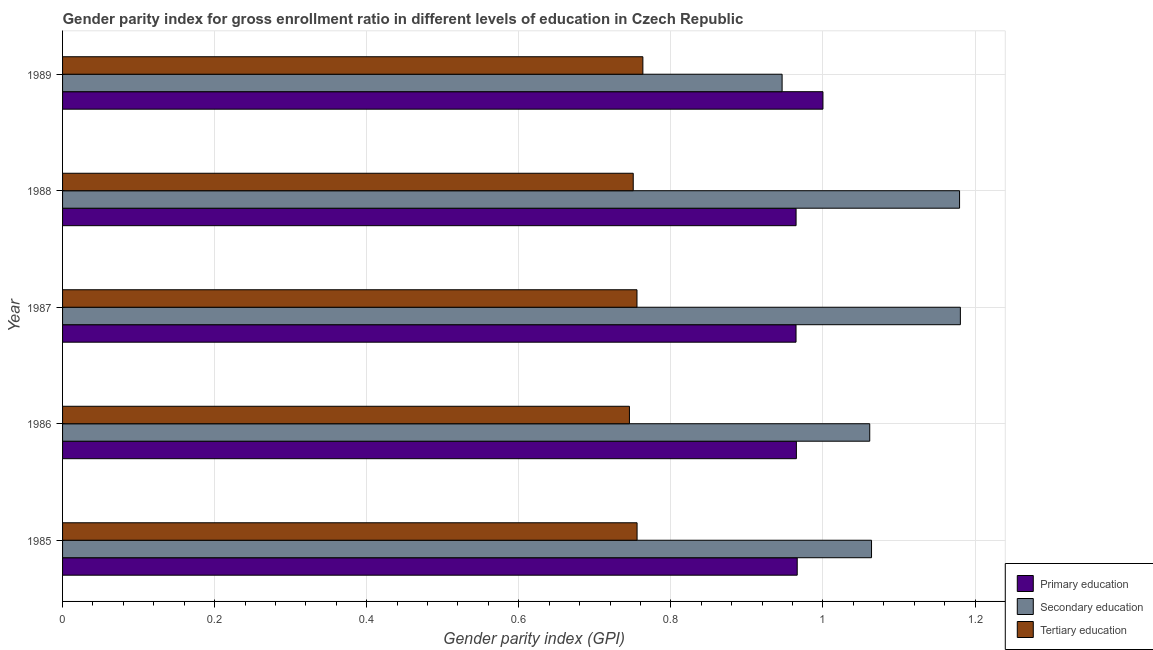How many different coloured bars are there?
Offer a terse response. 3. Are the number of bars per tick equal to the number of legend labels?
Offer a terse response. Yes. Are the number of bars on each tick of the Y-axis equal?
Offer a terse response. Yes. What is the label of the 1st group of bars from the top?
Your answer should be very brief. 1989. In how many cases, is the number of bars for a given year not equal to the number of legend labels?
Provide a short and direct response. 0. What is the gender parity index in secondary education in 1986?
Your response must be concise. 1.06. Across all years, what is the maximum gender parity index in primary education?
Provide a succinct answer. 1. Across all years, what is the minimum gender parity index in primary education?
Offer a very short reply. 0.96. In which year was the gender parity index in tertiary education maximum?
Offer a very short reply. 1989. In which year was the gender parity index in secondary education minimum?
Offer a terse response. 1989. What is the total gender parity index in secondary education in the graph?
Your response must be concise. 5.43. What is the difference between the gender parity index in secondary education in 1987 and that in 1988?
Your answer should be very brief. 0. What is the difference between the gender parity index in tertiary education in 1987 and the gender parity index in primary education in 1986?
Provide a short and direct response. -0.21. What is the average gender parity index in primary education per year?
Give a very brief answer. 0.97. In the year 1985, what is the difference between the gender parity index in secondary education and gender parity index in primary education?
Provide a succinct answer. 0.1. In how many years, is the gender parity index in primary education greater than 0.04 ?
Offer a very short reply. 5. What is the ratio of the gender parity index in primary education in 1985 to that in 1986?
Your response must be concise. 1. Is the gender parity index in primary education in 1985 less than that in 1989?
Offer a terse response. Yes. Is the difference between the gender parity index in secondary education in 1985 and 1986 greater than the difference between the gender parity index in primary education in 1985 and 1986?
Offer a terse response. Yes. What is the difference between the highest and the second highest gender parity index in secondary education?
Offer a terse response. 0. What is the difference between the highest and the lowest gender parity index in tertiary education?
Your answer should be very brief. 0.02. What does the 1st bar from the top in 1985 represents?
Keep it short and to the point. Tertiary education. What does the 1st bar from the bottom in 1985 represents?
Your answer should be very brief. Primary education. Is it the case that in every year, the sum of the gender parity index in primary education and gender parity index in secondary education is greater than the gender parity index in tertiary education?
Provide a succinct answer. Yes. Are all the bars in the graph horizontal?
Keep it short and to the point. Yes. How many years are there in the graph?
Provide a short and direct response. 5. Does the graph contain any zero values?
Make the answer very short. No. Where does the legend appear in the graph?
Make the answer very short. Bottom right. How are the legend labels stacked?
Make the answer very short. Vertical. What is the title of the graph?
Offer a terse response. Gender parity index for gross enrollment ratio in different levels of education in Czech Republic. What is the label or title of the X-axis?
Make the answer very short. Gender parity index (GPI). What is the Gender parity index (GPI) of Primary education in 1985?
Make the answer very short. 0.97. What is the Gender parity index (GPI) in Secondary education in 1985?
Make the answer very short. 1.06. What is the Gender parity index (GPI) in Tertiary education in 1985?
Your response must be concise. 0.76. What is the Gender parity index (GPI) in Primary education in 1986?
Provide a succinct answer. 0.97. What is the Gender parity index (GPI) in Secondary education in 1986?
Give a very brief answer. 1.06. What is the Gender parity index (GPI) in Tertiary education in 1986?
Offer a very short reply. 0.75. What is the Gender parity index (GPI) of Primary education in 1987?
Your answer should be very brief. 0.96. What is the Gender parity index (GPI) of Secondary education in 1987?
Offer a very short reply. 1.18. What is the Gender parity index (GPI) of Tertiary education in 1987?
Ensure brevity in your answer.  0.76. What is the Gender parity index (GPI) in Primary education in 1988?
Provide a succinct answer. 0.96. What is the Gender parity index (GPI) in Secondary education in 1988?
Provide a short and direct response. 1.18. What is the Gender parity index (GPI) of Tertiary education in 1988?
Your response must be concise. 0.75. What is the Gender parity index (GPI) of Primary education in 1989?
Your answer should be compact. 1. What is the Gender parity index (GPI) of Secondary education in 1989?
Provide a short and direct response. 0.95. What is the Gender parity index (GPI) in Tertiary education in 1989?
Offer a terse response. 0.76. Across all years, what is the maximum Gender parity index (GPI) in Primary education?
Give a very brief answer. 1. Across all years, what is the maximum Gender parity index (GPI) in Secondary education?
Provide a succinct answer. 1.18. Across all years, what is the maximum Gender parity index (GPI) in Tertiary education?
Offer a terse response. 0.76. Across all years, what is the minimum Gender parity index (GPI) in Primary education?
Offer a terse response. 0.96. Across all years, what is the minimum Gender parity index (GPI) of Secondary education?
Provide a short and direct response. 0.95. Across all years, what is the minimum Gender parity index (GPI) in Tertiary education?
Make the answer very short. 0.75. What is the total Gender parity index (GPI) in Primary education in the graph?
Offer a very short reply. 4.86. What is the total Gender parity index (GPI) in Secondary education in the graph?
Provide a succinct answer. 5.43. What is the total Gender parity index (GPI) in Tertiary education in the graph?
Give a very brief answer. 3.77. What is the difference between the Gender parity index (GPI) in Primary education in 1985 and that in 1986?
Provide a succinct answer. 0. What is the difference between the Gender parity index (GPI) in Secondary education in 1985 and that in 1986?
Keep it short and to the point. 0. What is the difference between the Gender parity index (GPI) in Tertiary education in 1985 and that in 1986?
Make the answer very short. 0.01. What is the difference between the Gender parity index (GPI) of Primary education in 1985 and that in 1987?
Offer a terse response. 0. What is the difference between the Gender parity index (GPI) of Secondary education in 1985 and that in 1987?
Provide a succinct answer. -0.12. What is the difference between the Gender parity index (GPI) of Primary education in 1985 and that in 1988?
Offer a very short reply. 0. What is the difference between the Gender parity index (GPI) in Secondary education in 1985 and that in 1988?
Make the answer very short. -0.12. What is the difference between the Gender parity index (GPI) in Tertiary education in 1985 and that in 1988?
Your answer should be very brief. 0.01. What is the difference between the Gender parity index (GPI) in Primary education in 1985 and that in 1989?
Offer a very short reply. -0.03. What is the difference between the Gender parity index (GPI) of Secondary education in 1985 and that in 1989?
Ensure brevity in your answer.  0.12. What is the difference between the Gender parity index (GPI) of Tertiary education in 1985 and that in 1989?
Offer a very short reply. -0.01. What is the difference between the Gender parity index (GPI) of Primary education in 1986 and that in 1987?
Offer a very short reply. 0. What is the difference between the Gender parity index (GPI) in Secondary education in 1986 and that in 1987?
Make the answer very short. -0.12. What is the difference between the Gender parity index (GPI) of Tertiary education in 1986 and that in 1987?
Keep it short and to the point. -0.01. What is the difference between the Gender parity index (GPI) in Secondary education in 1986 and that in 1988?
Provide a short and direct response. -0.12. What is the difference between the Gender parity index (GPI) in Tertiary education in 1986 and that in 1988?
Keep it short and to the point. -0.01. What is the difference between the Gender parity index (GPI) in Primary education in 1986 and that in 1989?
Your response must be concise. -0.03. What is the difference between the Gender parity index (GPI) in Secondary education in 1986 and that in 1989?
Ensure brevity in your answer.  0.12. What is the difference between the Gender parity index (GPI) of Tertiary education in 1986 and that in 1989?
Offer a terse response. -0.02. What is the difference between the Gender parity index (GPI) of Primary education in 1987 and that in 1988?
Your answer should be compact. -0. What is the difference between the Gender parity index (GPI) of Secondary education in 1987 and that in 1988?
Your answer should be very brief. 0. What is the difference between the Gender parity index (GPI) of Tertiary education in 1987 and that in 1988?
Make the answer very short. 0. What is the difference between the Gender parity index (GPI) in Primary education in 1987 and that in 1989?
Offer a very short reply. -0.04. What is the difference between the Gender parity index (GPI) in Secondary education in 1987 and that in 1989?
Keep it short and to the point. 0.23. What is the difference between the Gender parity index (GPI) of Tertiary education in 1987 and that in 1989?
Ensure brevity in your answer.  -0.01. What is the difference between the Gender parity index (GPI) in Primary education in 1988 and that in 1989?
Ensure brevity in your answer.  -0.04. What is the difference between the Gender parity index (GPI) of Secondary education in 1988 and that in 1989?
Offer a terse response. 0.23. What is the difference between the Gender parity index (GPI) in Tertiary education in 1988 and that in 1989?
Provide a succinct answer. -0.01. What is the difference between the Gender parity index (GPI) in Primary education in 1985 and the Gender parity index (GPI) in Secondary education in 1986?
Your answer should be very brief. -0.1. What is the difference between the Gender parity index (GPI) in Primary education in 1985 and the Gender parity index (GPI) in Tertiary education in 1986?
Make the answer very short. 0.22. What is the difference between the Gender parity index (GPI) of Secondary education in 1985 and the Gender parity index (GPI) of Tertiary education in 1986?
Give a very brief answer. 0.32. What is the difference between the Gender parity index (GPI) in Primary education in 1985 and the Gender parity index (GPI) in Secondary education in 1987?
Your response must be concise. -0.21. What is the difference between the Gender parity index (GPI) of Primary education in 1985 and the Gender parity index (GPI) of Tertiary education in 1987?
Offer a very short reply. 0.21. What is the difference between the Gender parity index (GPI) in Secondary education in 1985 and the Gender parity index (GPI) in Tertiary education in 1987?
Keep it short and to the point. 0.31. What is the difference between the Gender parity index (GPI) in Primary education in 1985 and the Gender parity index (GPI) in Secondary education in 1988?
Offer a terse response. -0.21. What is the difference between the Gender parity index (GPI) of Primary education in 1985 and the Gender parity index (GPI) of Tertiary education in 1988?
Your answer should be very brief. 0.22. What is the difference between the Gender parity index (GPI) in Secondary education in 1985 and the Gender parity index (GPI) in Tertiary education in 1988?
Your answer should be very brief. 0.31. What is the difference between the Gender parity index (GPI) in Primary education in 1985 and the Gender parity index (GPI) in Secondary education in 1989?
Provide a succinct answer. 0.02. What is the difference between the Gender parity index (GPI) of Primary education in 1985 and the Gender parity index (GPI) of Tertiary education in 1989?
Your answer should be compact. 0.2. What is the difference between the Gender parity index (GPI) of Secondary education in 1985 and the Gender parity index (GPI) of Tertiary education in 1989?
Offer a terse response. 0.3. What is the difference between the Gender parity index (GPI) in Primary education in 1986 and the Gender parity index (GPI) in Secondary education in 1987?
Ensure brevity in your answer.  -0.22. What is the difference between the Gender parity index (GPI) of Primary education in 1986 and the Gender parity index (GPI) of Tertiary education in 1987?
Provide a succinct answer. 0.21. What is the difference between the Gender parity index (GPI) in Secondary education in 1986 and the Gender parity index (GPI) in Tertiary education in 1987?
Offer a very short reply. 0.31. What is the difference between the Gender parity index (GPI) in Primary education in 1986 and the Gender parity index (GPI) in Secondary education in 1988?
Your response must be concise. -0.21. What is the difference between the Gender parity index (GPI) in Primary education in 1986 and the Gender parity index (GPI) in Tertiary education in 1988?
Offer a terse response. 0.21. What is the difference between the Gender parity index (GPI) of Secondary education in 1986 and the Gender parity index (GPI) of Tertiary education in 1988?
Give a very brief answer. 0.31. What is the difference between the Gender parity index (GPI) in Primary education in 1986 and the Gender parity index (GPI) in Secondary education in 1989?
Provide a short and direct response. 0.02. What is the difference between the Gender parity index (GPI) of Primary education in 1986 and the Gender parity index (GPI) of Tertiary education in 1989?
Your response must be concise. 0.2. What is the difference between the Gender parity index (GPI) of Secondary education in 1986 and the Gender parity index (GPI) of Tertiary education in 1989?
Your answer should be compact. 0.3. What is the difference between the Gender parity index (GPI) of Primary education in 1987 and the Gender parity index (GPI) of Secondary education in 1988?
Keep it short and to the point. -0.22. What is the difference between the Gender parity index (GPI) of Primary education in 1987 and the Gender parity index (GPI) of Tertiary education in 1988?
Your answer should be very brief. 0.21. What is the difference between the Gender parity index (GPI) in Secondary education in 1987 and the Gender parity index (GPI) in Tertiary education in 1988?
Give a very brief answer. 0.43. What is the difference between the Gender parity index (GPI) in Primary education in 1987 and the Gender parity index (GPI) in Secondary education in 1989?
Your answer should be very brief. 0.02. What is the difference between the Gender parity index (GPI) of Primary education in 1987 and the Gender parity index (GPI) of Tertiary education in 1989?
Make the answer very short. 0.2. What is the difference between the Gender parity index (GPI) of Secondary education in 1987 and the Gender parity index (GPI) of Tertiary education in 1989?
Provide a short and direct response. 0.42. What is the difference between the Gender parity index (GPI) in Primary education in 1988 and the Gender parity index (GPI) in Secondary education in 1989?
Give a very brief answer. 0.02. What is the difference between the Gender parity index (GPI) of Primary education in 1988 and the Gender parity index (GPI) of Tertiary education in 1989?
Keep it short and to the point. 0.2. What is the difference between the Gender parity index (GPI) of Secondary education in 1988 and the Gender parity index (GPI) of Tertiary education in 1989?
Give a very brief answer. 0.42. What is the average Gender parity index (GPI) of Primary education per year?
Make the answer very short. 0.97. What is the average Gender parity index (GPI) of Secondary education per year?
Provide a succinct answer. 1.09. What is the average Gender parity index (GPI) in Tertiary education per year?
Give a very brief answer. 0.75. In the year 1985, what is the difference between the Gender parity index (GPI) in Primary education and Gender parity index (GPI) in Secondary education?
Your answer should be compact. -0.1. In the year 1985, what is the difference between the Gender parity index (GPI) of Primary education and Gender parity index (GPI) of Tertiary education?
Provide a short and direct response. 0.21. In the year 1985, what is the difference between the Gender parity index (GPI) in Secondary education and Gender parity index (GPI) in Tertiary education?
Keep it short and to the point. 0.31. In the year 1986, what is the difference between the Gender parity index (GPI) of Primary education and Gender parity index (GPI) of Secondary education?
Offer a terse response. -0.1. In the year 1986, what is the difference between the Gender parity index (GPI) of Primary education and Gender parity index (GPI) of Tertiary education?
Provide a succinct answer. 0.22. In the year 1986, what is the difference between the Gender parity index (GPI) of Secondary education and Gender parity index (GPI) of Tertiary education?
Your response must be concise. 0.32. In the year 1987, what is the difference between the Gender parity index (GPI) of Primary education and Gender parity index (GPI) of Secondary education?
Ensure brevity in your answer.  -0.22. In the year 1987, what is the difference between the Gender parity index (GPI) in Primary education and Gender parity index (GPI) in Tertiary education?
Your answer should be very brief. 0.21. In the year 1987, what is the difference between the Gender parity index (GPI) in Secondary education and Gender parity index (GPI) in Tertiary education?
Provide a short and direct response. 0.43. In the year 1988, what is the difference between the Gender parity index (GPI) of Primary education and Gender parity index (GPI) of Secondary education?
Provide a short and direct response. -0.21. In the year 1988, what is the difference between the Gender parity index (GPI) of Primary education and Gender parity index (GPI) of Tertiary education?
Provide a succinct answer. 0.21. In the year 1988, what is the difference between the Gender parity index (GPI) in Secondary education and Gender parity index (GPI) in Tertiary education?
Give a very brief answer. 0.43. In the year 1989, what is the difference between the Gender parity index (GPI) in Primary education and Gender parity index (GPI) in Secondary education?
Give a very brief answer. 0.05. In the year 1989, what is the difference between the Gender parity index (GPI) in Primary education and Gender parity index (GPI) in Tertiary education?
Offer a terse response. 0.24. In the year 1989, what is the difference between the Gender parity index (GPI) in Secondary education and Gender parity index (GPI) in Tertiary education?
Keep it short and to the point. 0.18. What is the ratio of the Gender parity index (GPI) of Tertiary education in 1985 to that in 1986?
Keep it short and to the point. 1.01. What is the ratio of the Gender parity index (GPI) of Primary education in 1985 to that in 1987?
Make the answer very short. 1. What is the ratio of the Gender parity index (GPI) of Secondary education in 1985 to that in 1987?
Offer a terse response. 0.9. What is the ratio of the Gender parity index (GPI) of Primary education in 1985 to that in 1988?
Your answer should be very brief. 1. What is the ratio of the Gender parity index (GPI) of Secondary education in 1985 to that in 1988?
Offer a terse response. 0.9. What is the ratio of the Gender parity index (GPI) in Tertiary education in 1985 to that in 1988?
Your response must be concise. 1.01. What is the ratio of the Gender parity index (GPI) of Primary education in 1985 to that in 1989?
Give a very brief answer. 0.97. What is the ratio of the Gender parity index (GPI) of Secondary education in 1985 to that in 1989?
Provide a short and direct response. 1.12. What is the ratio of the Gender parity index (GPI) in Tertiary education in 1985 to that in 1989?
Your answer should be compact. 0.99. What is the ratio of the Gender parity index (GPI) in Secondary education in 1986 to that in 1987?
Give a very brief answer. 0.9. What is the ratio of the Gender parity index (GPI) of Tertiary education in 1986 to that in 1987?
Give a very brief answer. 0.99. What is the ratio of the Gender parity index (GPI) in Secondary education in 1986 to that in 1988?
Provide a short and direct response. 0.9. What is the ratio of the Gender parity index (GPI) in Primary education in 1986 to that in 1989?
Provide a succinct answer. 0.97. What is the ratio of the Gender parity index (GPI) in Secondary education in 1986 to that in 1989?
Keep it short and to the point. 1.12. What is the ratio of the Gender parity index (GPI) of Tertiary education in 1986 to that in 1989?
Your answer should be very brief. 0.98. What is the ratio of the Gender parity index (GPI) in Primary education in 1987 to that in 1988?
Offer a very short reply. 1. What is the ratio of the Gender parity index (GPI) of Tertiary education in 1987 to that in 1988?
Keep it short and to the point. 1.01. What is the ratio of the Gender parity index (GPI) of Primary education in 1987 to that in 1989?
Provide a succinct answer. 0.96. What is the ratio of the Gender parity index (GPI) of Secondary education in 1987 to that in 1989?
Keep it short and to the point. 1.25. What is the ratio of the Gender parity index (GPI) of Primary education in 1988 to that in 1989?
Keep it short and to the point. 0.96. What is the ratio of the Gender parity index (GPI) of Secondary education in 1988 to that in 1989?
Keep it short and to the point. 1.25. What is the ratio of the Gender parity index (GPI) in Tertiary education in 1988 to that in 1989?
Keep it short and to the point. 0.98. What is the difference between the highest and the second highest Gender parity index (GPI) of Primary education?
Your answer should be very brief. 0.03. What is the difference between the highest and the second highest Gender parity index (GPI) of Secondary education?
Provide a short and direct response. 0. What is the difference between the highest and the second highest Gender parity index (GPI) of Tertiary education?
Make the answer very short. 0.01. What is the difference between the highest and the lowest Gender parity index (GPI) in Primary education?
Provide a succinct answer. 0.04. What is the difference between the highest and the lowest Gender parity index (GPI) in Secondary education?
Your answer should be compact. 0.23. What is the difference between the highest and the lowest Gender parity index (GPI) of Tertiary education?
Offer a terse response. 0.02. 